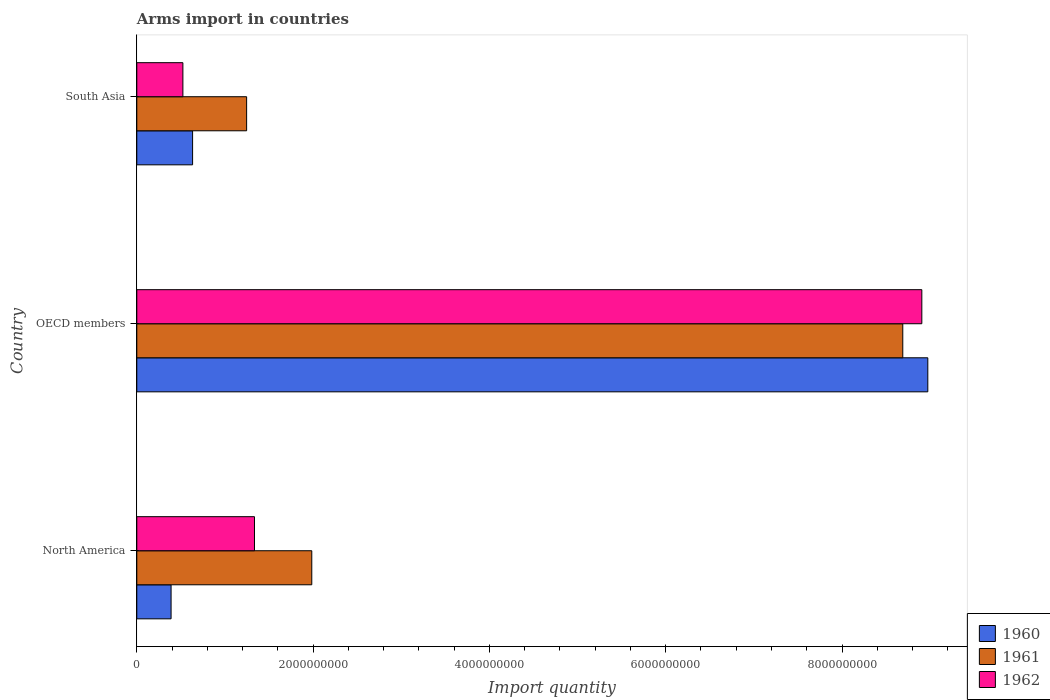What is the label of the 3rd group of bars from the top?
Your answer should be very brief. North America. In how many cases, is the number of bars for a given country not equal to the number of legend labels?
Keep it short and to the point. 0. What is the total arms import in 1960 in OECD members?
Ensure brevity in your answer.  8.97e+09. Across all countries, what is the maximum total arms import in 1961?
Provide a succinct answer. 8.69e+09. Across all countries, what is the minimum total arms import in 1960?
Make the answer very short. 3.89e+08. In which country was the total arms import in 1960 maximum?
Offer a very short reply. OECD members. In which country was the total arms import in 1961 minimum?
Offer a terse response. South Asia. What is the total total arms import in 1960 in the graph?
Offer a very short reply. 1.00e+1. What is the difference between the total arms import in 1962 in North America and that in OECD members?
Your answer should be compact. -7.57e+09. What is the difference between the total arms import in 1961 in South Asia and the total arms import in 1962 in OECD members?
Your answer should be compact. -7.66e+09. What is the average total arms import in 1962 per country?
Give a very brief answer. 3.59e+09. What is the difference between the total arms import in 1961 and total arms import in 1960 in OECD members?
Keep it short and to the point. -2.84e+08. In how many countries, is the total arms import in 1962 greater than 8000000000 ?
Make the answer very short. 1. What is the ratio of the total arms import in 1961 in North America to that in South Asia?
Offer a terse response. 1.59. What is the difference between the highest and the second highest total arms import in 1962?
Provide a succinct answer. 7.57e+09. What is the difference between the highest and the lowest total arms import in 1962?
Your response must be concise. 8.38e+09. In how many countries, is the total arms import in 1961 greater than the average total arms import in 1961 taken over all countries?
Offer a terse response. 1. What does the 1st bar from the bottom in OECD members represents?
Provide a succinct answer. 1960. Are the values on the major ticks of X-axis written in scientific E-notation?
Your response must be concise. No. Does the graph contain any zero values?
Your response must be concise. No. Does the graph contain grids?
Give a very brief answer. No. Where does the legend appear in the graph?
Ensure brevity in your answer.  Bottom right. How many legend labels are there?
Offer a terse response. 3. What is the title of the graph?
Ensure brevity in your answer.  Arms import in countries. What is the label or title of the X-axis?
Ensure brevity in your answer.  Import quantity. What is the label or title of the Y-axis?
Offer a very short reply. Country. What is the Import quantity of 1960 in North America?
Offer a very short reply. 3.89e+08. What is the Import quantity in 1961 in North America?
Your answer should be very brief. 1.98e+09. What is the Import quantity of 1962 in North America?
Offer a terse response. 1.34e+09. What is the Import quantity in 1960 in OECD members?
Your response must be concise. 8.97e+09. What is the Import quantity of 1961 in OECD members?
Your response must be concise. 8.69e+09. What is the Import quantity in 1962 in OECD members?
Keep it short and to the point. 8.90e+09. What is the Import quantity in 1960 in South Asia?
Your response must be concise. 6.33e+08. What is the Import quantity in 1961 in South Asia?
Make the answer very short. 1.25e+09. What is the Import quantity in 1962 in South Asia?
Provide a short and direct response. 5.23e+08. Across all countries, what is the maximum Import quantity of 1960?
Your answer should be very brief. 8.97e+09. Across all countries, what is the maximum Import quantity in 1961?
Keep it short and to the point. 8.69e+09. Across all countries, what is the maximum Import quantity in 1962?
Ensure brevity in your answer.  8.90e+09. Across all countries, what is the minimum Import quantity in 1960?
Offer a very short reply. 3.89e+08. Across all countries, what is the minimum Import quantity in 1961?
Provide a short and direct response. 1.25e+09. Across all countries, what is the minimum Import quantity in 1962?
Make the answer very short. 5.23e+08. What is the total Import quantity of 1960 in the graph?
Ensure brevity in your answer.  1.00e+1. What is the total Import quantity of 1961 in the graph?
Provide a succinct answer. 1.19e+1. What is the total Import quantity of 1962 in the graph?
Provide a short and direct response. 1.08e+1. What is the difference between the Import quantity of 1960 in North America and that in OECD members?
Ensure brevity in your answer.  -8.58e+09. What is the difference between the Import quantity of 1961 in North America and that in OECD members?
Give a very brief answer. -6.70e+09. What is the difference between the Import quantity of 1962 in North America and that in OECD members?
Offer a terse response. -7.57e+09. What is the difference between the Import quantity in 1960 in North America and that in South Asia?
Your answer should be very brief. -2.44e+08. What is the difference between the Import quantity of 1961 in North America and that in South Asia?
Your answer should be very brief. 7.39e+08. What is the difference between the Import quantity in 1962 in North America and that in South Asia?
Your answer should be compact. 8.12e+08. What is the difference between the Import quantity in 1960 in OECD members and that in South Asia?
Keep it short and to the point. 8.34e+09. What is the difference between the Import quantity of 1961 in OECD members and that in South Asia?
Give a very brief answer. 7.44e+09. What is the difference between the Import quantity of 1962 in OECD members and that in South Asia?
Ensure brevity in your answer.  8.38e+09. What is the difference between the Import quantity in 1960 in North America and the Import quantity in 1961 in OECD members?
Offer a very short reply. -8.30e+09. What is the difference between the Import quantity of 1960 in North America and the Import quantity of 1962 in OECD members?
Your answer should be very brief. -8.52e+09. What is the difference between the Import quantity in 1961 in North America and the Import quantity in 1962 in OECD members?
Your answer should be very brief. -6.92e+09. What is the difference between the Import quantity of 1960 in North America and the Import quantity of 1961 in South Asia?
Offer a terse response. -8.57e+08. What is the difference between the Import quantity in 1960 in North America and the Import quantity in 1962 in South Asia?
Ensure brevity in your answer.  -1.34e+08. What is the difference between the Import quantity of 1961 in North America and the Import quantity of 1962 in South Asia?
Your response must be concise. 1.46e+09. What is the difference between the Import quantity in 1960 in OECD members and the Import quantity in 1961 in South Asia?
Your response must be concise. 7.73e+09. What is the difference between the Import quantity in 1960 in OECD members and the Import quantity in 1962 in South Asia?
Your answer should be very brief. 8.45e+09. What is the difference between the Import quantity of 1961 in OECD members and the Import quantity of 1962 in South Asia?
Your response must be concise. 8.17e+09. What is the average Import quantity in 1960 per country?
Provide a short and direct response. 3.33e+09. What is the average Import quantity of 1961 per country?
Offer a terse response. 3.97e+09. What is the average Import quantity in 1962 per country?
Give a very brief answer. 3.59e+09. What is the difference between the Import quantity of 1960 and Import quantity of 1961 in North America?
Offer a terse response. -1.60e+09. What is the difference between the Import quantity of 1960 and Import quantity of 1962 in North America?
Give a very brief answer. -9.46e+08. What is the difference between the Import quantity of 1961 and Import quantity of 1962 in North America?
Give a very brief answer. 6.50e+08. What is the difference between the Import quantity in 1960 and Import quantity in 1961 in OECD members?
Your response must be concise. 2.84e+08. What is the difference between the Import quantity of 1960 and Import quantity of 1962 in OECD members?
Offer a very short reply. 6.80e+07. What is the difference between the Import quantity in 1961 and Import quantity in 1962 in OECD members?
Keep it short and to the point. -2.16e+08. What is the difference between the Import quantity of 1960 and Import quantity of 1961 in South Asia?
Offer a very short reply. -6.13e+08. What is the difference between the Import quantity in 1960 and Import quantity in 1962 in South Asia?
Offer a very short reply. 1.10e+08. What is the difference between the Import quantity of 1961 and Import quantity of 1962 in South Asia?
Your answer should be very brief. 7.23e+08. What is the ratio of the Import quantity of 1960 in North America to that in OECD members?
Give a very brief answer. 0.04. What is the ratio of the Import quantity of 1961 in North America to that in OECD members?
Give a very brief answer. 0.23. What is the ratio of the Import quantity in 1962 in North America to that in OECD members?
Offer a very short reply. 0.15. What is the ratio of the Import quantity of 1960 in North America to that in South Asia?
Provide a short and direct response. 0.61. What is the ratio of the Import quantity of 1961 in North America to that in South Asia?
Your response must be concise. 1.59. What is the ratio of the Import quantity in 1962 in North America to that in South Asia?
Offer a very short reply. 2.55. What is the ratio of the Import quantity of 1960 in OECD members to that in South Asia?
Your answer should be compact. 14.18. What is the ratio of the Import quantity of 1961 in OECD members to that in South Asia?
Your response must be concise. 6.97. What is the ratio of the Import quantity in 1962 in OECD members to that in South Asia?
Your answer should be compact. 17.03. What is the difference between the highest and the second highest Import quantity of 1960?
Provide a short and direct response. 8.34e+09. What is the difference between the highest and the second highest Import quantity of 1961?
Provide a succinct answer. 6.70e+09. What is the difference between the highest and the second highest Import quantity in 1962?
Ensure brevity in your answer.  7.57e+09. What is the difference between the highest and the lowest Import quantity of 1960?
Provide a succinct answer. 8.58e+09. What is the difference between the highest and the lowest Import quantity of 1961?
Ensure brevity in your answer.  7.44e+09. What is the difference between the highest and the lowest Import quantity in 1962?
Keep it short and to the point. 8.38e+09. 